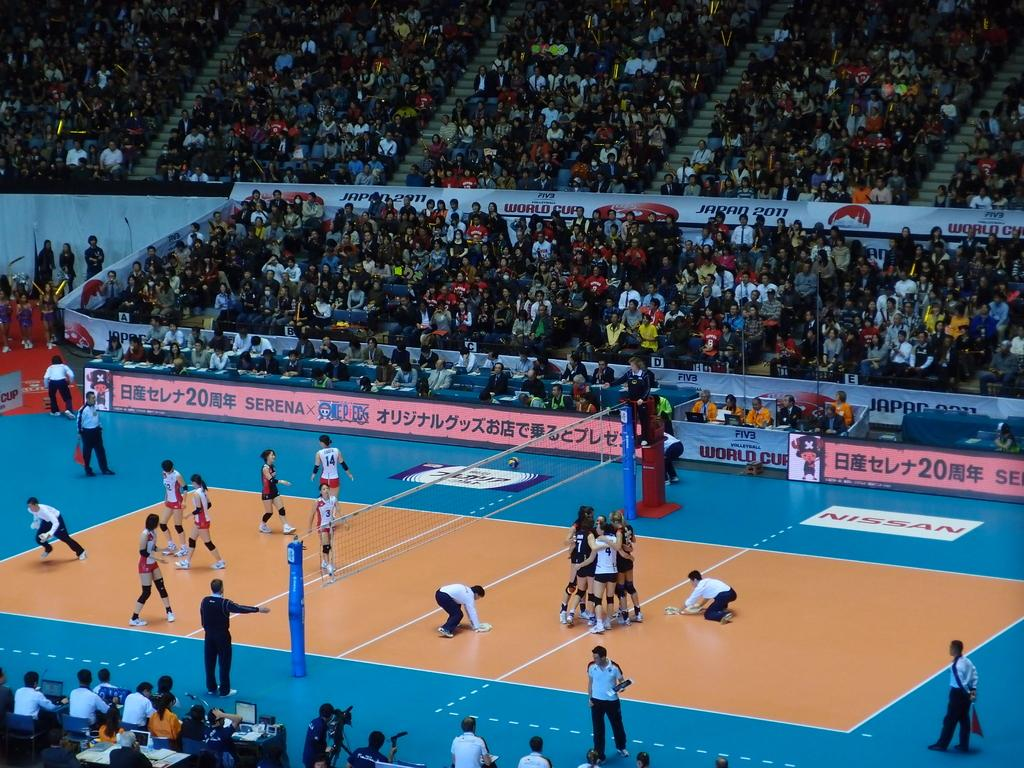<image>
Render a clear and concise summary of the photo. A woman's volley ball game sponsored by Nissan 